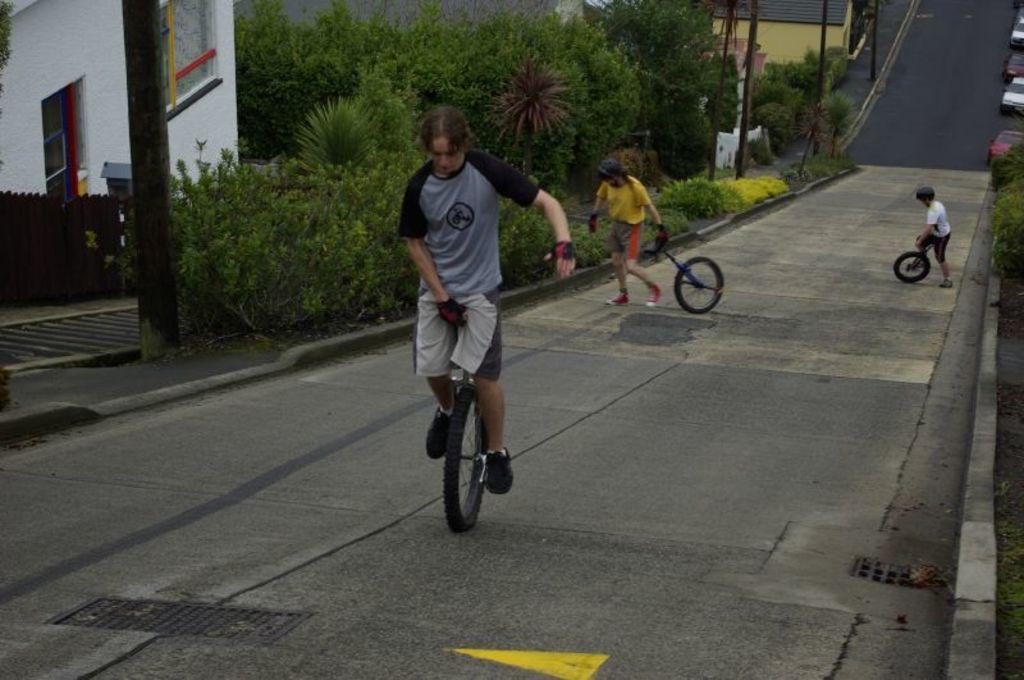Could you give a brief overview of what you see in this image? In this image we can see three persons on the road. Here we can see a person riding a unicycle and in the background there are two persons holding unicycles. Here we can see plants, trees, poles, houses, and vehicles. 